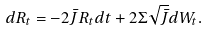<formula> <loc_0><loc_0><loc_500><loc_500>d R _ { t } = - 2 \bar { J } R _ { t } d t + 2 \Sigma \sqrt { \bar { J } } d W _ { t } .</formula> 